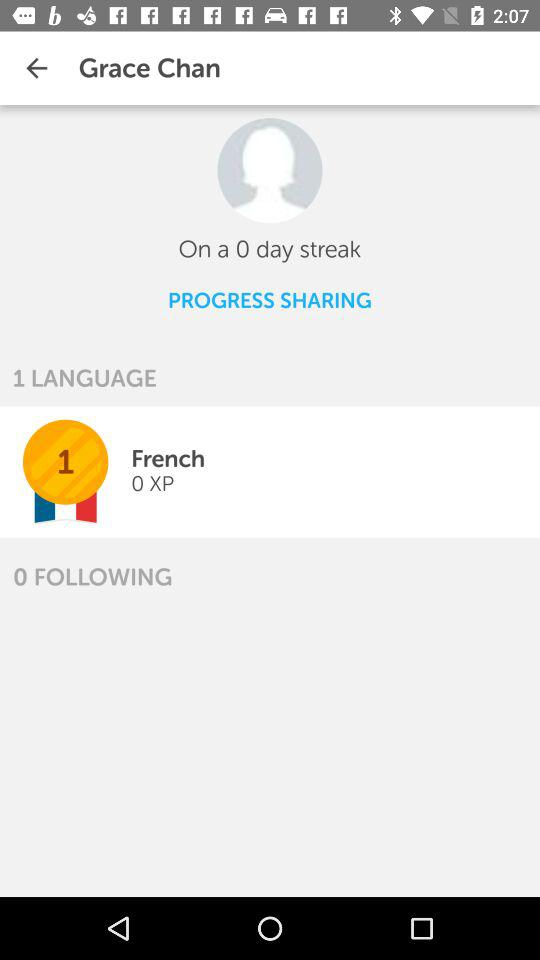What language is given? The language is French. 